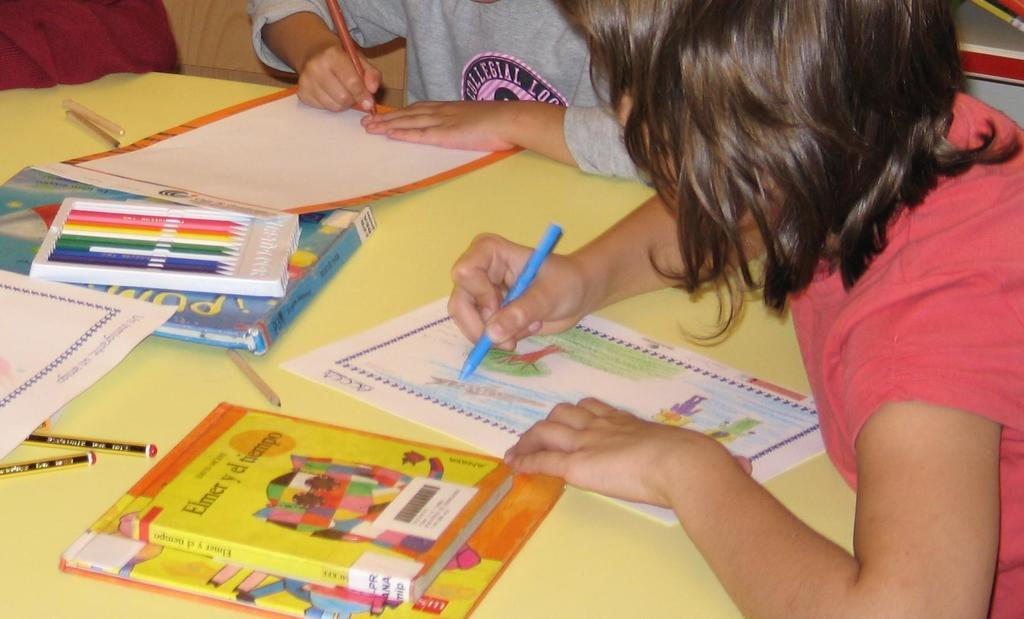What is the main piece of furniture in the image? There is a table in the image. What items can be seen on the table? There are books and pens on the table. How many people are in the image? There are two persons in the image. What are the two persons holding? The two persons are holding pens. Where are the two persons sitting in relation to the table? The two persons are sitting in front of the table. Can you tell me how many stamps are on the table in the image? There is no mention of stamps in the image; only books and pens are present on the table. 